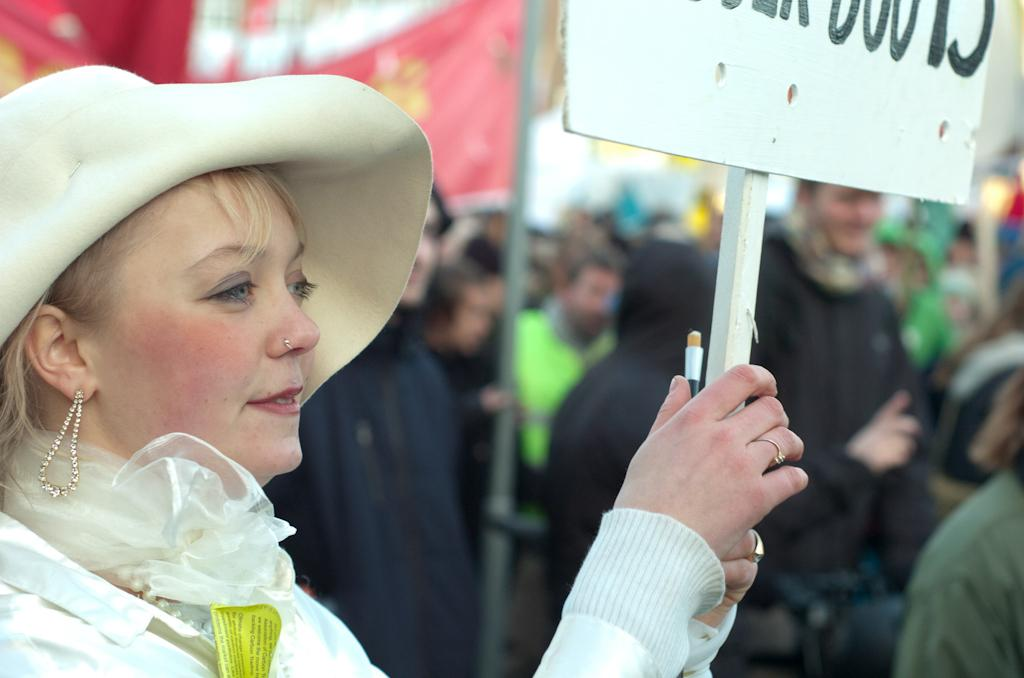Who is the main subject in the image? There is a woman in the image. What is the woman holding in the image? The woman is holding a board. What type of headwear is the woman wearing? The woman is wearing a cap. What can be seen in the background of the image? There is a banner attached to a pole in the background, and there are people present as well. What type of boot is the woman wearing in the image? The woman is not wearing a boot in the image; she is wearing a cap. How many chickens are visible in the image? There are no chickens present in the image. 